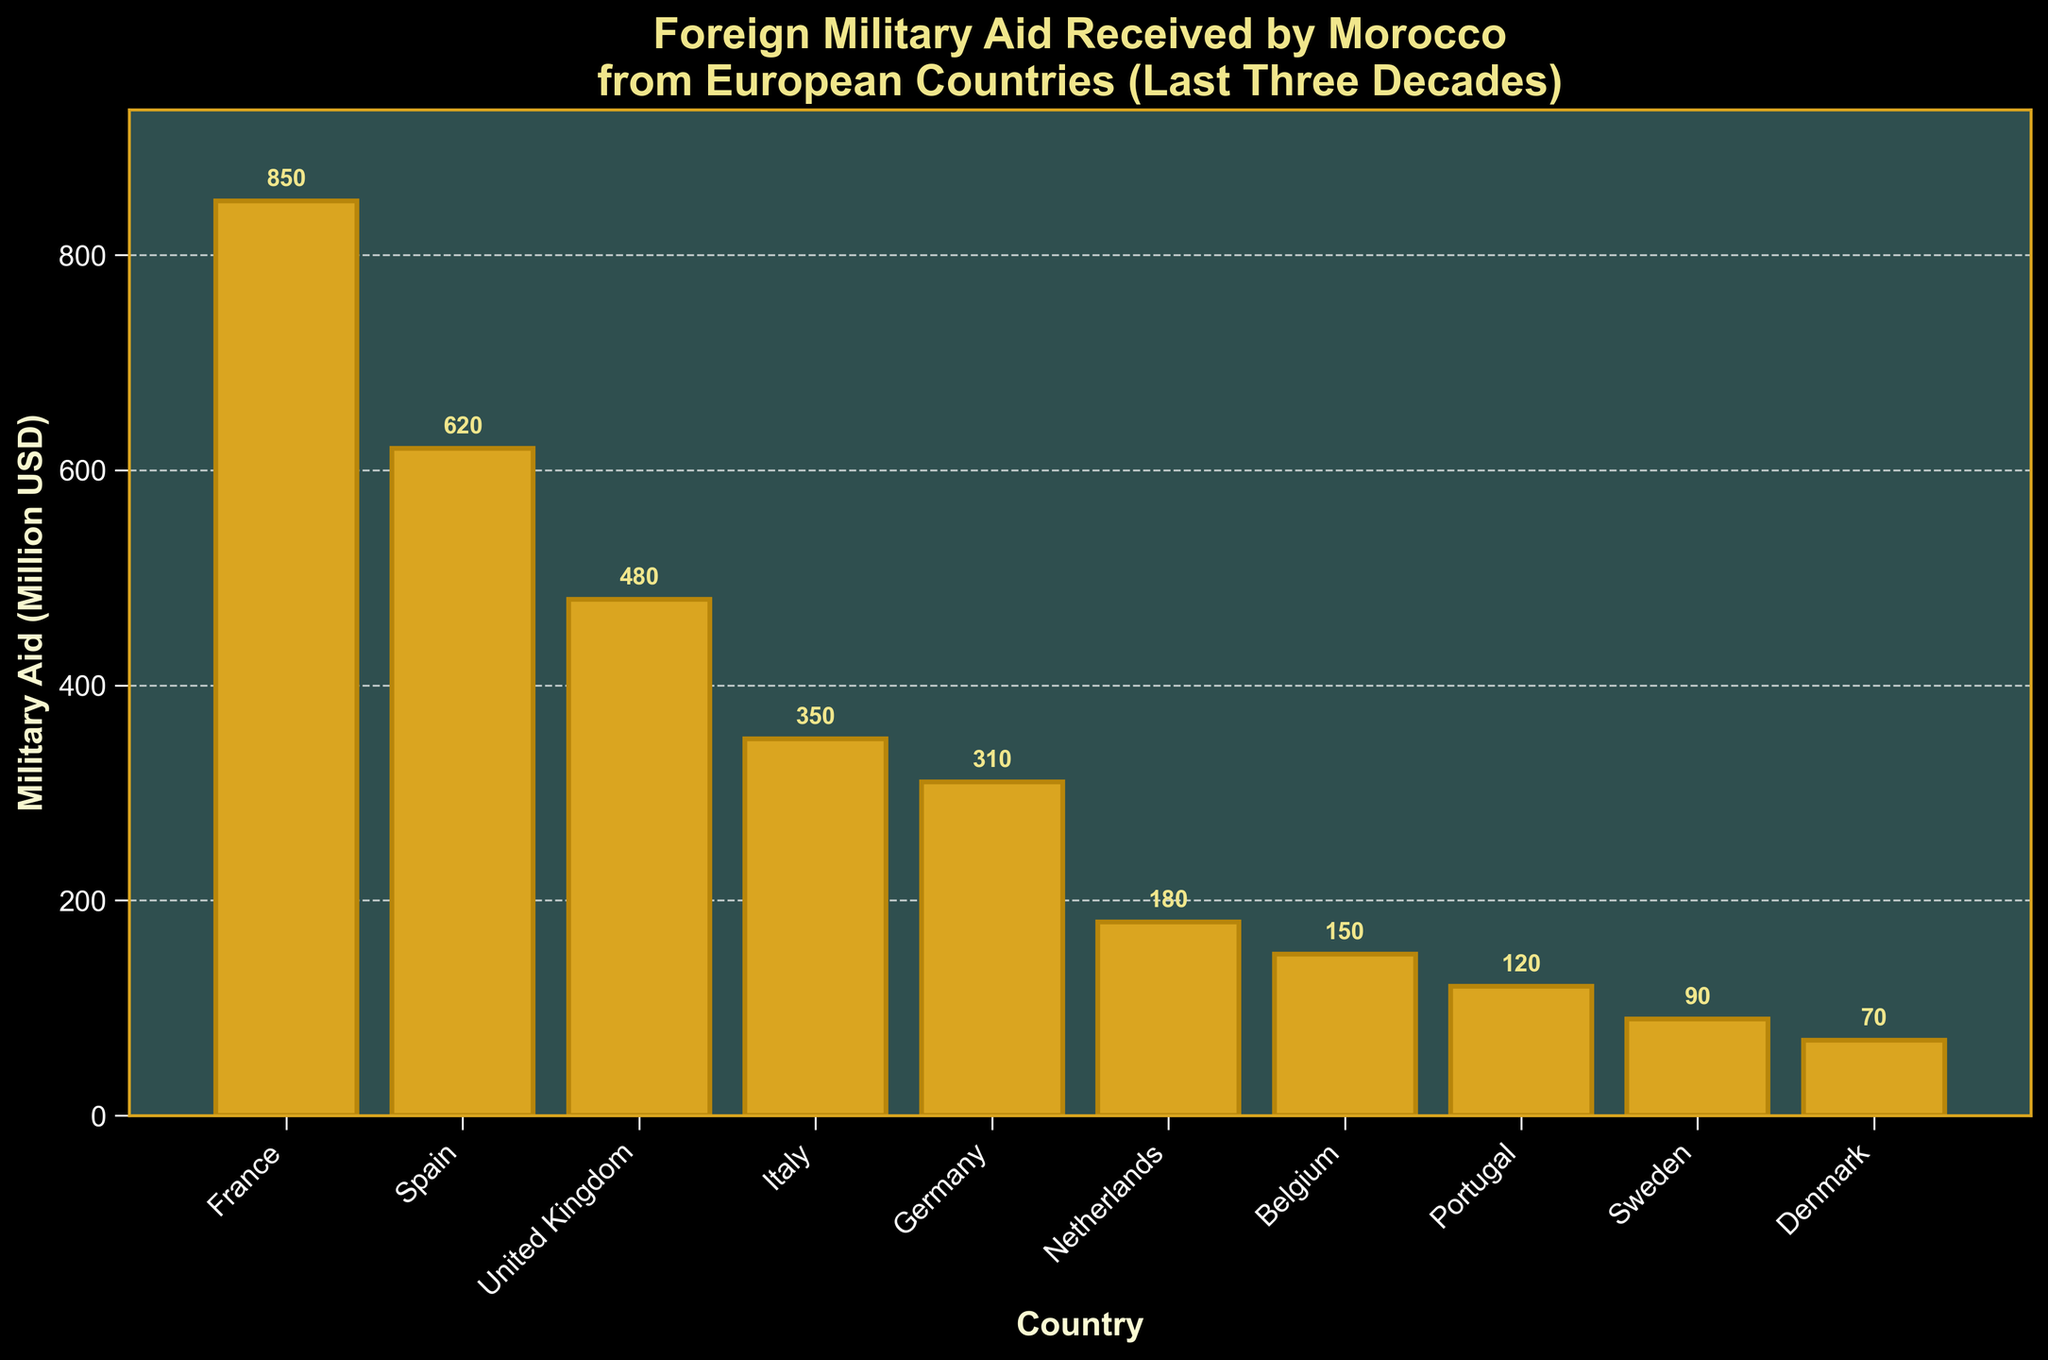Which country provided the highest military aid to Morocco? France's bar is the tallest in the figure. Therefore, France provided the highest military aid to Morocco.
Answer: France Which country provided the least military aid to Morocco? Denmark's bar is the shortest in the figure. Therefore, Denmark provided the least military aid to Morocco.
Answer: Denmark How much more aid did France provide compared to Germany? The height of France's bar represents 850 million USD, and Germany's bar represents 310 million USD. The difference is 850 - 310.
Answer: 540 million USD What is the total military aid provided by the United Kingdom and Italy combined? The United Kingdom provided 480 million USD, and Italy provided 350 million USD. The sum is 480 + 350.
Answer: 830 million USD Which countries provided less than 200 million USD in military aid? By observing the figure, the bars representing the Netherlands, Belgium, Portugal, Sweden, and Denmark are all below 200 on the y-axis.
Answer: Netherlands, Belgium, Portugal, Sweden, Denmark What is the average military aid received from all the countries listed? Summing all the aid values: 850 + 620 + 480 + 350 + 310 + 180 + 150 + 120 + 90 + 70 = 3220 million USD. There are 10 countries, so the average is 3220 / 10.
Answer: 322 million USD Is the aid received from Spain more or less than that from Germany and the UK combined? The aid from the UK and Germany combined is 480 + 310 = 790 million USD. The aid from Spain is 620 million USD. 620 is less than 790, so Spain's aid is less.
Answer: Less What percentage of the total aid was provided by France? France provided 850 million USD out of the total 3220 million USD. The percentage is (850 / 3220) * 100.
Answer: ~26.4% How many countries provided more than 300 million USD in aid? France, Spain, the United Kingdom, Italy, and Germany all provided more than 300 million USD in aid.
Answer: 5 Which countries' aid is between that of Portugal and Italy? Based on the figure, the countries with aid amounts between Portugal's 120 million USD and Italy's 350 million USD are Germany (310 million USD) and the Netherlands (180 million USD).
Answer: Germany, Netherlands 